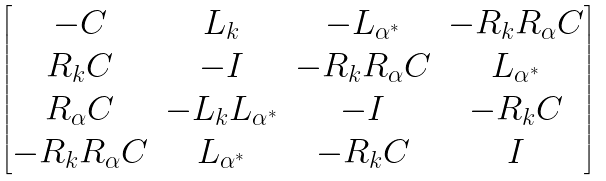<formula> <loc_0><loc_0><loc_500><loc_500>\begin{bmatrix} - C & L _ { k } & - L _ { \alpha ^ { * } } & - R _ { k } R _ { \alpha } C \\ R _ { k } C & - I & - R _ { k } R _ { \alpha } C & L _ { \alpha ^ { * } } \\ R _ { \alpha } C & - L _ { k } L _ { \alpha ^ { * } } & - I & - R _ { k } C \\ - R _ { k } R _ { \alpha } C & L _ { \alpha ^ { * } } & - R _ { k } C & I \end{bmatrix}</formula> 